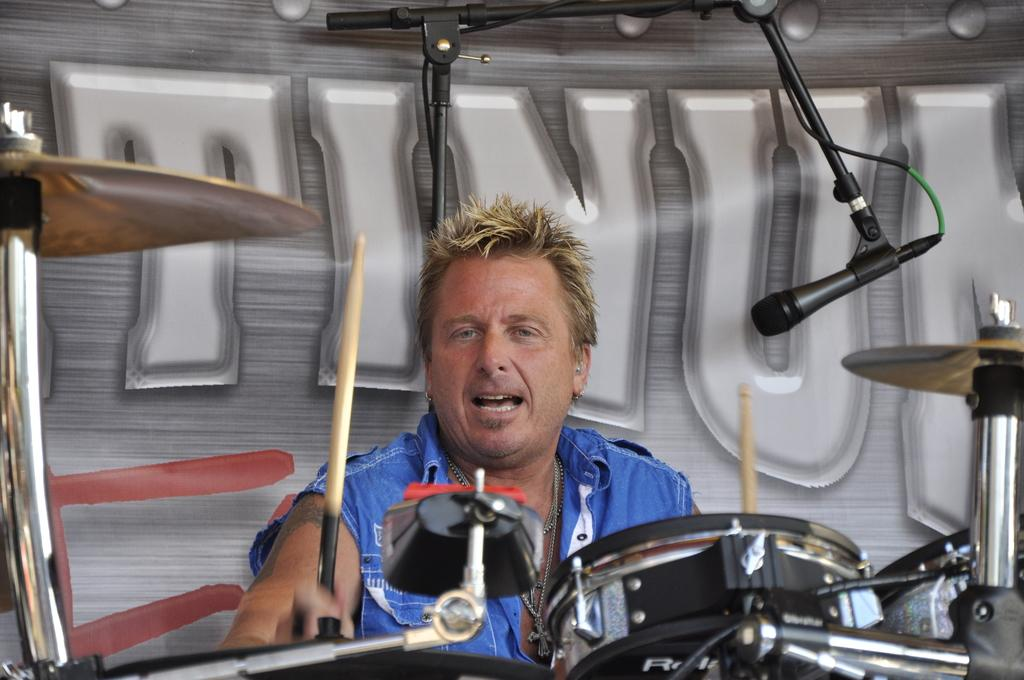Who or what is present in the image? There is a person in the image. What object is associated with the person in the image? There is a microphone (mic) and a mic stand in the image. What other items can be seen in the image? There are sticks (possibly drumsticks) and musical instruments in the image. What can be seen in the background of the image? There is a wall in the background of the image. What is written on the wall? Something is written on the wall. What type of tooth is visible in the image? There is no tooth visible in the image. What is the person wearing on their wrist in the image? There is no information about the person's wrist or any accessories they might be wearing in the image. 